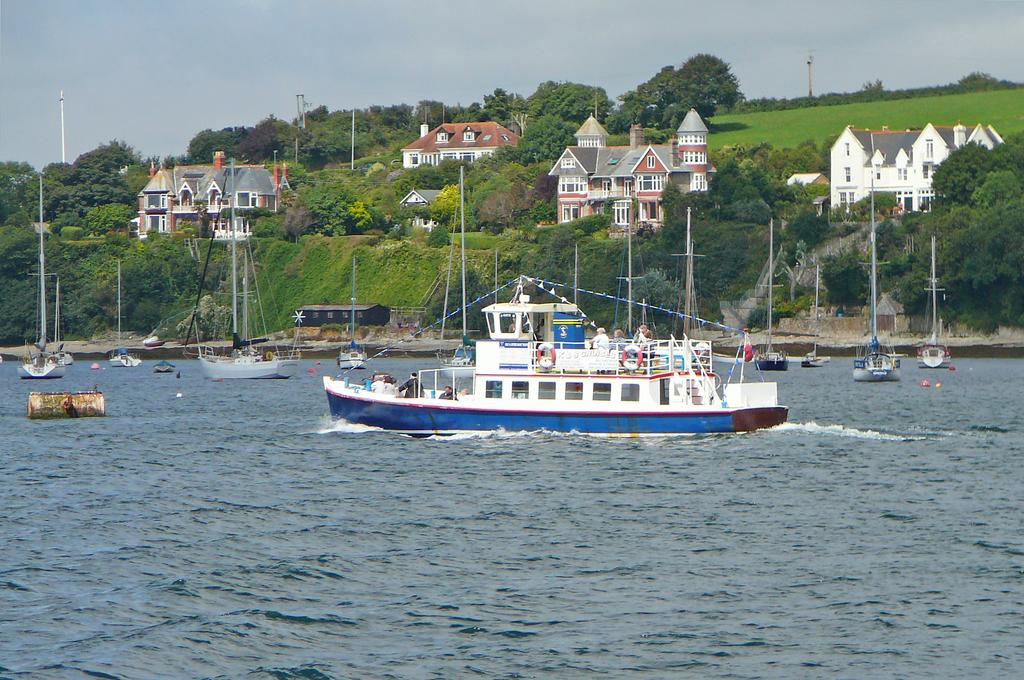What is happening to the boats in the image? The boats are above the water in the image. Who is present in the image? People are present in the image. What structures can be seen in the image? Poles are visible in the image. What else is present in the image? Ropes are present in the image. What can be seen in the background of the image? Trees, buildings, grass, and the sky are visible in the background of the image. Where is the sugar patch located in the image? There is no sugar patch present in the image. What sign is visible in the image? There is no sign visible in the image. 